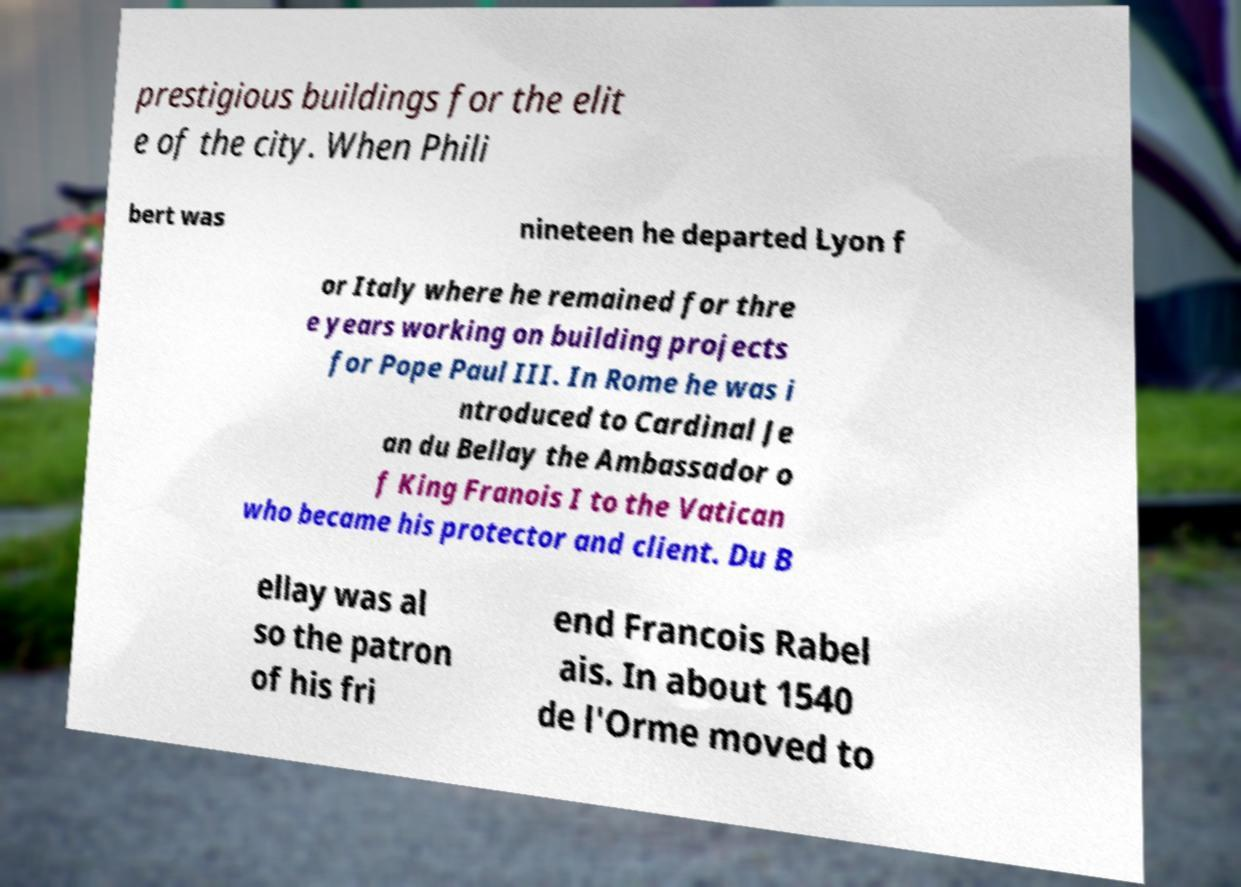Please identify and transcribe the text found in this image. prestigious buildings for the elit e of the city. When Phili bert was nineteen he departed Lyon f or Italy where he remained for thre e years working on building projects for Pope Paul III. In Rome he was i ntroduced to Cardinal Je an du Bellay the Ambassador o f King Franois I to the Vatican who became his protector and client. Du B ellay was al so the patron of his fri end Francois Rabel ais. In about 1540 de l'Orme moved to 